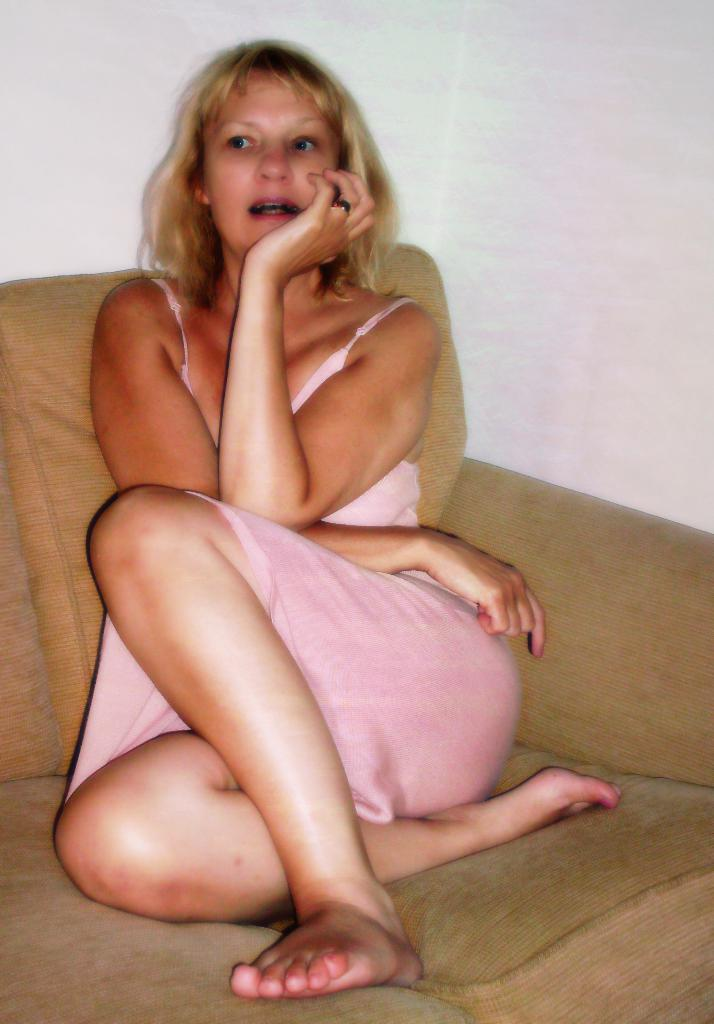Who is the main subject in the image? There is a woman in the image. What is the woman doing in the image? The woman is sitting on a sofa. What can be seen in the background of the image? A: There is a wall in the background of the image. What is the woman's opinion on the birth of the new king in the image? There is no mention of a new king or any opinions in the image. 